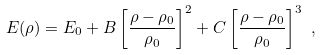<formula> <loc_0><loc_0><loc_500><loc_500>E ( \rho ) = E _ { 0 } + B \left [ \frac { \rho - \rho _ { 0 } } { \rho _ { 0 } } \right ] ^ { 2 } + C \left [ \frac { \rho - \rho _ { 0 } } { \rho _ { 0 } } \right ] ^ { 3 } \ ,</formula> 